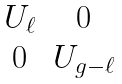Convert formula to latex. <formula><loc_0><loc_0><loc_500><loc_500>\begin{matrix} U _ { \ell } & 0 \\ 0 & U _ { g - \ell } \end{matrix}</formula> 